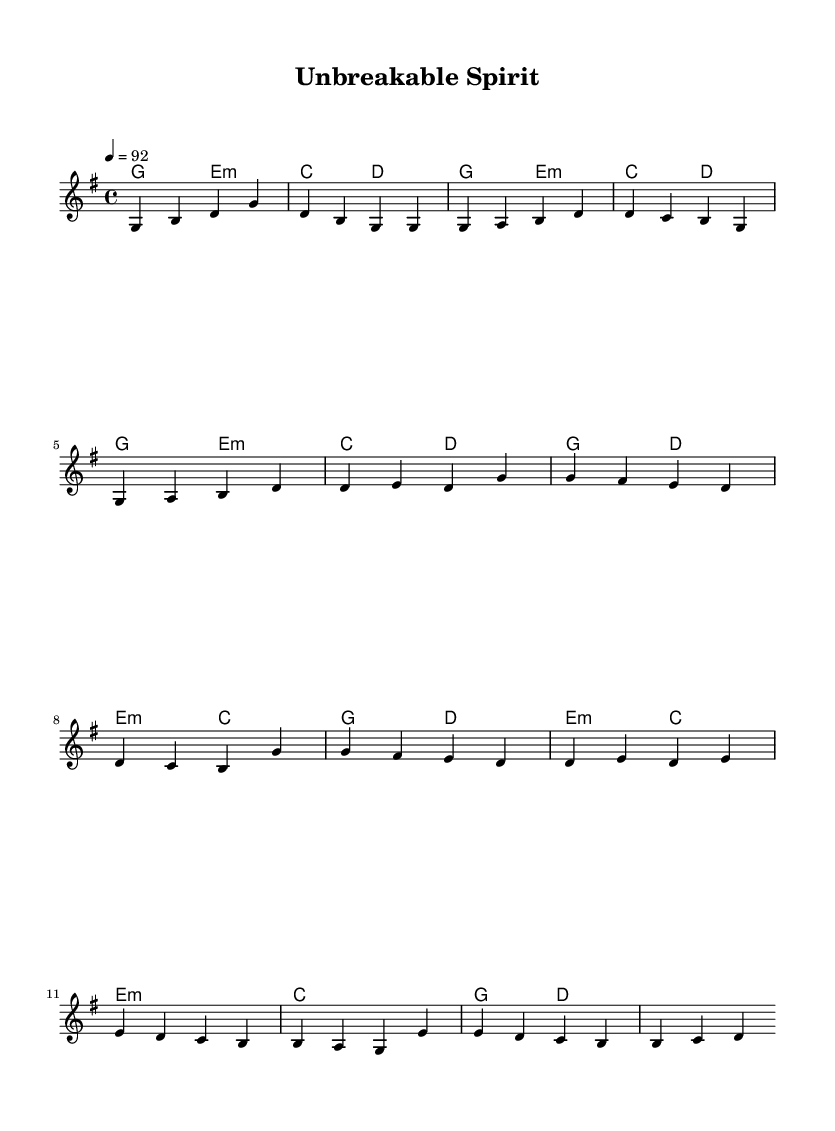What is the key signature of this music? The key signature is G major, which has one sharp (F#).
Answer: G major What is the time signature of the piece? The time signature shown in the music is 4/4, meaning there are four beats in a measure.
Answer: 4/4 What is the tempo marking for this music? The tempo marking indicates a speed of quarter note equals 92 beats per minute.
Answer: 92 How many measures are in the verse section? The verse section consists of four measures, as indicated by the grouping of notes.
Answer: 4 What type of musical piece is this? This piece is a rap song, as indicated by its rhythm and lyrical content.
Answer: Rap In which section does the chorus appear? The chorus can be found after the verse, typically indicated by a change in melody and harmony.
Answer: After the verse What is the chord progression in the intro? The chord progression for the intro is G, E minor, C, D, which is given in the harmonies.
Answer: G, E minor, C, D 